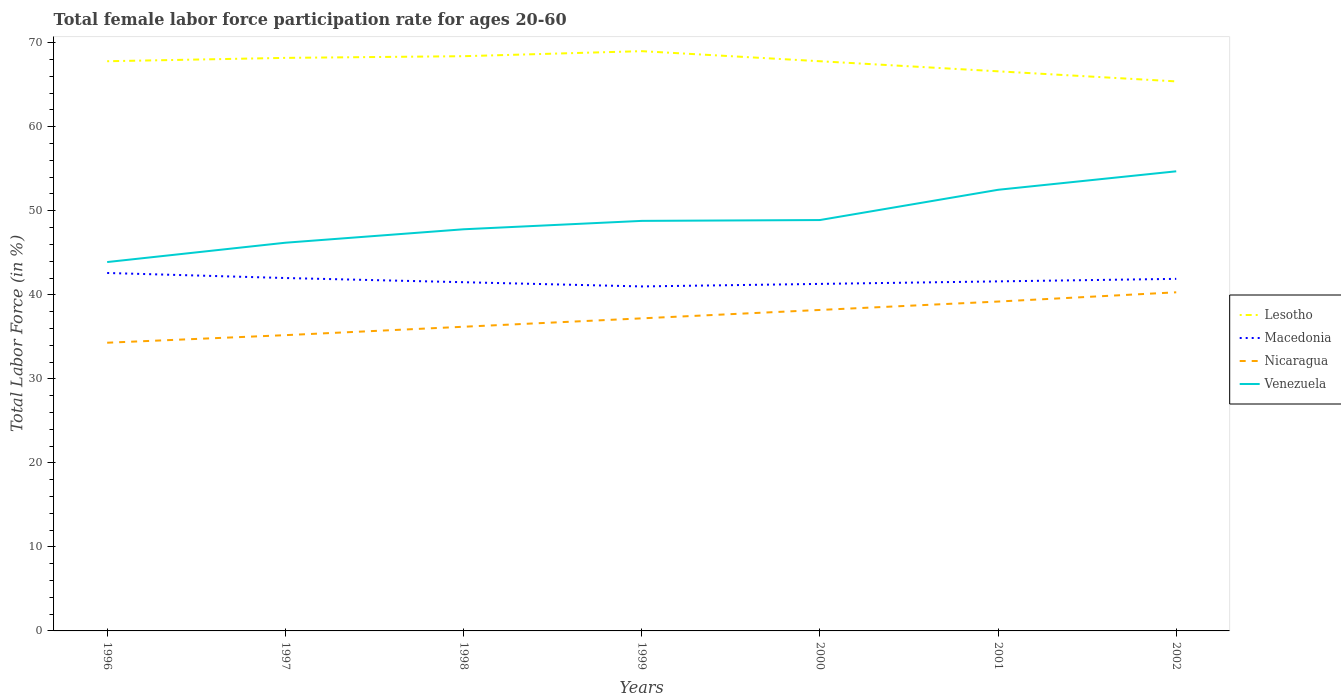Does the line corresponding to Venezuela intersect with the line corresponding to Nicaragua?
Offer a very short reply. No. Is the number of lines equal to the number of legend labels?
Make the answer very short. Yes. Across all years, what is the maximum female labor force participation rate in Lesotho?
Make the answer very short. 65.4. What is the total female labor force participation rate in Venezuela in the graph?
Provide a short and direct response. -8.6. What is the difference between the highest and the second highest female labor force participation rate in Macedonia?
Keep it short and to the point. 1.6. Is the female labor force participation rate in Macedonia strictly greater than the female labor force participation rate in Venezuela over the years?
Your response must be concise. Yes. How many lines are there?
Make the answer very short. 4. How many years are there in the graph?
Provide a short and direct response. 7. Are the values on the major ticks of Y-axis written in scientific E-notation?
Provide a succinct answer. No. Does the graph contain any zero values?
Provide a succinct answer. No. How are the legend labels stacked?
Your answer should be very brief. Vertical. What is the title of the graph?
Provide a short and direct response. Total female labor force participation rate for ages 20-60. Does "Turkey" appear as one of the legend labels in the graph?
Offer a terse response. No. What is the label or title of the X-axis?
Keep it short and to the point. Years. What is the Total Labor Force (in %) in Lesotho in 1996?
Ensure brevity in your answer.  67.8. What is the Total Labor Force (in %) of Macedonia in 1996?
Offer a terse response. 42.6. What is the Total Labor Force (in %) of Nicaragua in 1996?
Your answer should be very brief. 34.3. What is the Total Labor Force (in %) in Venezuela in 1996?
Offer a terse response. 43.9. What is the Total Labor Force (in %) in Lesotho in 1997?
Make the answer very short. 68.2. What is the Total Labor Force (in %) of Macedonia in 1997?
Provide a short and direct response. 42. What is the Total Labor Force (in %) in Nicaragua in 1997?
Ensure brevity in your answer.  35.2. What is the Total Labor Force (in %) in Venezuela in 1997?
Your response must be concise. 46.2. What is the Total Labor Force (in %) in Lesotho in 1998?
Provide a short and direct response. 68.4. What is the Total Labor Force (in %) of Macedonia in 1998?
Give a very brief answer. 41.5. What is the Total Labor Force (in %) in Nicaragua in 1998?
Ensure brevity in your answer.  36.2. What is the Total Labor Force (in %) in Venezuela in 1998?
Make the answer very short. 47.8. What is the Total Labor Force (in %) in Nicaragua in 1999?
Offer a very short reply. 37.2. What is the Total Labor Force (in %) in Venezuela in 1999?
Keep it short and to the point. 48.8. What is the Total Labor Force (in %) of Lesotho in 2000?
Give a very brief answer. 67.8. What is the Total Labor Force (in %) of Macedonia in 2000?
Your answer should be very brief. 41.3. What is the Total Labor Force (in %) in Nicaragua in 2000?
Make the answer very short. 38.2. What is the Total Labor Force (in %) of Venezuela in 2000?
Give a very brief answer. 48.9. What is the Total Labor Force (in %) of Lesotho in 2001?
Provide a succinct answer. 66.6. What is the Total Labor Force (in %) of Macedonia in 2001?
Provide a succinct answer. 41.6. What is the Total Labor Force (in %) of Nicaragua in 2001?
Ensure brevity in your answer.  39.2. What is the Total Labor Force (in %) of Venezuela in 2001?
Ensure brevity in your answer.  52.5. What is the Total Labor Force (in %) of Lesotho in 2002?
Provide a succinct answer. 65.4. What is the Total Labor Force (in %) in Macedonia in 2002?
Keep it short and to the point. 41.9. What is the Total Labor Force (in %) in Nicaragua in 2002?
Give a very brief answer. 40.3. What is the Total Labor Force (in %) in Venezuela in 2002?
Your answer should be compact. 54.7. Across all years, what is the maximum Total Labor Force (in %) of Macedonia?
Your answer should be very brief. 42.6. Across all years, what is the maximum Total Labor Force (in %) in Nicaragua?
Ensure brevity in your answer.  40.3. Across all years, what is the maximum Total Labor Force (in %) of Venezuela?
Make the answer very short. 54.7. Across all years, what is the minimum Total Labor Force (in %) of Lesotho?
Offer a very short reply. 65.4. Across all years, what is the minimum Total Labor Force (in %) of Nicaragua?
Your answer should be compact. 34.3. Across all years, what is the minimum Total Labor Force (in %) in Venezuela?
Keep it short and to the point. 43.9. What is the total Total Labor Force (in %) in Lesotho in the graph?
Keep it short and to the point. 473.2. What is the total Total Labor Force (in %) of Macedonia in the graph?
Give a very brief answer. 291.9. What is the total Total Labor Force (in %) of Nicaragua in the graph?
Provide a succinct answer. 260.6. What is the total Total Labor Force (in %) in Venezuela in the graph?
Provide a short and direct response. 342.8. What is the difference between the Total Labor Force (in %) of Macedonia in 1996 and that in 1997?
Your response must be concise. 0.6. What is the difference between the Total Labor Force (in %) in Venezuela in 1996 and that in 1997?
Ensure brevity in your answer.  -2.3. What is the difference between the Total Labor Force (in %) in Lesotho in 1996 and that in 1998?
Offer a terse response. -0.6. What is the difference between the Total Labor Force (in %) in Macedonia in 1996 and that in 1998?
Give a very brief answer. 1.1. What is the difference between the Total Labor Force (in %) of Nicaragua in 1996 and that in 1998?
Ensure brevity in your answer.  -1.9. What is the difference between the Total Labor Force (in %) in Macedonia in 1996 and that in 1999?
Make the answer very short. 1.6. What is the difference between the Total Labor Force (in %) of Lesotho in 1996 and that in 2000?
Keep it short and to the point. 0. What is the difference between the Total Labor Force (in %) of Macedonia in 1996 and that in 2000?
Offer a terse response. 1.3. What is the difference between the Total Labor Force (in %) in Venezuela in 1996 and that in 2000?
Provide a short and direct response. -5. What is the difference between the Total Labor Force (in %) of Macedonia in 1996 and that in 2001?
Keep it short and to the point. 1. What is the difference between the Total Labor Force (in %) of Lesotho in 1996 and that in 2002?
Give a very brief answer. 2.4. What is the difference between the Total Labor Force (in %) of Nicaragua in 1996 and that in 2002?
Your answer should be very brief. -6. What is the difference between the Total Labor Force (in %) in Nicaragua in 1997 and that in 1998?
Ensure brevity in your answer.  -1. What is the difference between the Total Labor Force (in %) in Lesotho in 1997 and that in 1999?
Ensure brevity in your answer.  -0.8. What is the difference between the Total Labor Force (in %) in Macedonia in 1997 and that in 1999?
Make the answer very short. 1. What is the difference between the Total Labor Force (in %) of Lesotho in 1997 and that in 2000?
Provide a succinct answer. 0.4. What is the difference between the Total Labor Force (in %) of Nicaragua in 1997 and that in 2000?
Keep it short and to the point. -3. What is the difference between the Total Labor Force (in %) of Venezuela in 1997 and that in 2000?
Your answer should be very brief. -2.7. What is the difference between the Total Labor Force (in %) of Lesotho in 1997 and that in 2001?
Offer a very short reply. 1.6. What is the difference between the Total Labor Force (in %) of Nicaragua in 1997 and that in 2001?
Offer a terse response. -4. What is the difference between the Total Labor Force (in %) in Venezuela in 1997 and that in 2002?
Ensure brevity in your answer.  -8.5. What is the difference between the Total Labor Force (in %) in Nicaragua in 1998 and that in 1999?
Your response must be concise. -1. What is the difference between the Total Labor Force (in %) in Lesotho in 1998 and that in 2000?
Make the answer very short. 0.6. What is the difference between the Total Labor Force (in %) in Venezuela in 1998 and that in 2000?
Provide a short and direct response. -1.1. What is the difference between the Total Labor Force (in %) in Macedonia in 1998 and that in 2001?
Give a very brief answer. -0.1. What is the difference between the Total Labor Force (in %) in Venezuela in 1998 and that in 2001?
Your answer should be compact. -4.7. What is the difference between the Total Labor Force (in %) in Macedonia in 1998 and that in 2002?
Keep it short and to the point. -0.4. What is the difference between the Total Labor Force (in %) in Venezuela in 1998 and that in 2002?
Provide a succinct answer. -6.9. What is the difference between the Total Labor Force (in %) of Lesotho in 1999 and that in 2000?
Ensure brevity in your answer.  1.2. What is the difference between the Total Labor Force (in %) of Macedonia in 1999 and that in 2000?
Ensure brevity in your answer.  -0.3. What is the difference between the Total Labor Force (in %) in Nicaragua in 1999 and that in 2000?
Offer a terse response. -1. What is the difference between the Total Labor Force (in %) of Nicaragua in 1999 and that in 2002?
Ensure brevity in your answer.  -3.1. What is the difference between the Total Labor Force (in %) of Venezuela in 1999 and that in 2002?
Ensure brevity in your answer.  -5.9. What is the difference between the Total Labor Force (in %) in Lesotho in 2000 and that in 2001?
Your answer should be very brief. 1.2. What is the difference between the Total Labor Force (in %) of Nicaragua in 2000 and that in 2001?
Make the answer very short. -1. What is the difference between the Total Labor Force (in %) of Nicaragua in 2000 and that in 2002?
Keep it short and to the point. -2.1. What is the difference between the Total Labor Force (in %) in Venezuela in 2000 and that in 2002?
Give a very brief answer. -5.8. What is the difference between the Total Labor Force (in %) in Nicaragua in 2001 and that in 2002?
Offer a terse response. -1.1. What is the difference between the Total Labor Force (in %) in Venezuela in 2001 and that in 2002?
Make the answer very short. -2.2. What is the difference between the Total Labor Force (in %) of Lesotho in 1996 and the Total Labor Force (in %) of Macedonia in 1997?
Offer a very short reply. 25.8. What is the difference between the Total Labor Force (in %) of Lesotho in 1996 and the Total Labor Force (in %) of Nicaragua in 1997?
Offer a very short reply. 32.6. What is the difference between the Total Labor Force (in %) in Lesotho in 1996 and the Total Labor Force (in %) in Venezuela in 1997?
Your answer should be compact. 21.6. What is the difference between the Total Labor Force (in %) in Macedonia in 1996 and the Total Labor Force (in %) in Venezuela in 1997?
Make the answer very short. -3.6. What is the difference between the Total Labor Force (in %) of Lesotho in 1996 and the Total Labor Force (in %) of Macedonia in 1998?
Provide a succinct answer. 26.3. What is the difference between the Total Labor Force (in %) of Lesotho in 1996 and the Total Labor Force (in %) of Nicaragua in 1998?
Ensure brevity in your answer.  31.6. What is the difference between the Total Labor Force (in %) of Lesotho in 1996 and the Total Labor Force (in %) of Venezuela in 1998?
Offer a very short reply. 20. What is the difference between the Total Labor Force (in %) of Macedonia in 1996 and the Total Labor Force (in %) of Venezuela in 1998?
Your response must be concise. -5.2. What is the difference between the Total Labor Force (in %) in Lesotho in 1996 and the Total Labor Force (in %) in Macedonia in 1999?
Ensure brevity in your answer.  26.8. What is the difference between the Total Labor Force (in %) of Lesotho in 1996 and the Total Labor Force (in %) of Nicaragua in 1999?
Give a very brief answer. 30.6. What is the difference between the Total Labor Force (in %) in Lesotho in 1996 and the Total Labor Force (in %) in Venezuela in 1999?
Your response must be concise. 19. What is the difference between the Total Labor Force (in %) in Macedonia in 1996 and the Total Labor Force (in %) in Venezuela in 1999?
Provide a succinct answer. -6.2. What is the difference between the Total Labor Force (in %) in Nicaragua in 1996 and the Total Labor Force (in %) in Venezuela in 1999?
Make the answer very short. -14.5. What is the difference between the Total Labor Force (in %) in Lesotho in 1996 and the Total Labor Force (in %) in Macedonia in 2000?
Your response must be concise. 26.5. What is the difference between the Total Labor Force (in %) of Lesotho in 1996 and the Total Labor Force (in %) of Nicaragua in 2000?
Your answer should be very brief. 29.6. What is the difference between the Total Labor Force (in %) in Nicaragua in 1996 and the Total Labor Force (in %) in Venezuela in 2000?
Ensure brevity in your answer.  -14.6. What is the difference between the Total Labor Force (in %) of Lesotho in 1996 and the Total Labor Force (in %) of Macedonia in 2001?
Your response must be concise. 26.2. What is the difference between the Total Labor Force (in %) of Lesotho in 1996 and the Total Labor Force (in %) of Nicaragua in 2001?
Offer a very short reply. 28.6. What is the difference between the Total Labor Force (in %) of Macedonia in 1996 and the Total Labor Force (in %) of Nicaragua in 2001?
Your answer should be compact. 3.4. What is the difference between the Total Labor Force (in %) in Macedonia in 1996 and the Total Labor Force (in %) in Venezuela in 2001?
Ensure brevity in your answer.  -9.9. What is the difference between the Total Labor Force (in %) of Nicaragua in 1996 and the Total Labor Force (in %) of Venezuela in 2001?
Give a very brief answer. -18.2. What is the difference between the Total Labor Force (in %) of Lesotho in 1996 and the Total Labor Force (in %) of Macedonia in 2002?
Offer a terse response. 25.9. What is the difference between the Total Labor Force (in %) in Lesotho in 1996 and the Total Labor Force (in %) in Nicaragua in 2002?
Your answer should be compact. 27.5. What is the difference between the Total Labor Force (in %) of Lesotho in 1996 and the Total Labor Force (in %) of Venezuela in 2002?
Offer a terse response. 13.1. What is the difference between the Total Labor Force (in %) of Nicaragua in 1996 and the Total Labor Force (in %) of Venezuela in 2002?
Make the answer very short. -20.4. What is the difference between the Total Labor Force (in %) in Lesotho in 1997 and the Total Labor Force (in %) in Macedonia in 1998?
Keep it short and to the point. 26.7. What is the difference between the Total Labor Force (in %) of Lesotho in 1997 and the Total Labor Force (in %) of Nicaragua in 1998?
Give a very brief answer. 32. What is the difference between the Total Labor Force (in %) in Lesotho in 1997 and the Total Labor Force (in %) in Venezuela in 1998?
Make the answer very short. 20.4. What is the difference between the Total Labor Force (in %) in Nicaragua in 1997 and the Total Labor Force (in %) in Venezuela in 1998?
Offer a very short reply. -12.6. What is the difference between the Total Labor Force (in %) in Lesotho in 1997 and the Total Labor Force (in %) in Macedonia in 1999?
Your answer should be compact. 27.2. What is the difference between the Total Labor Force (in %) of Macedonia in 1997 and the Total Labor Force (in %) of Venezuela in 1999?
Ensure brevity in your answer.  -6.8. What is the difference between the Total Labor Force (in %) of Lesotho in 1997 and the Total Labor Force (in %) of Macedonia in 2000?
Give a very brief answer. 26.9. What is the difference between the Total Labor Force (in %) of Lesotho in 1997 and the Total Labor Force (in %) of Nicaragua in 2000?
Provide a succinct answer. 30. What is the difference between the Total Labor Force (in %) of Lesotho in 1997 and the Total Labor Force (in %) of Venezuela in 2000?
Give a very brief answer. 19.3. What is the difference between the Total Labor Force (in %) of Macedonia in 1997 and the Total Labor Force (in %) of Nicaragua in 2000?
Make the answer very short. 3.8. What is the difference between the Total Labor Force (in %) in Nicaragua in 1997 and the Total Labor Force (in %) in Venezuela in 2000?
Keep it short and to the point. -13.7. What is the difference between the Total Labor Force (in %) in Lesotho in 1997 and the Total Labor Force (in %) in Macedonia in 2001?
Provide a succinct answer. 26.6. What is the difference between the Total Labor Force (in %) in Lesotho in 1997 and the Total Labor Force (in %) in Nicaragua in 2001?
Your answer should be compact. 29. What is the difference between the Total Labor Force (in %) of Macedonia in 1997 and the Total Labor Force (in %) of Venezuela in 2001?
Provide a short and direct response. -10.5. What is the difference between the Total Labor Force (in %) of Nicaragua in 1997 and the Total Labor Force (in %) of Venezuela in 2001?
Your response must be concise. -17.3. What is the difference between the Total Labor Force (in %) of Lesotho in 1997 and the Total Labor Force (in %) of Macedonia in 2002?
Give a very brief answer. 26.3. What is the difference between the Total Labor Force (in %) in Lesotho in 1997 and the Total Labor Force (in %) in Nicaragua in 2002?
Give a very brief answer. 27.9. What is the difference between the Total Labor Force (in %) of Macedonia in 1997 and the Total Labor Force (in %) of Nicaragua in 2002?
Ensure brevity in your answer.  1.7. What is the difference between the Total Labor Force (in %) in Nicaragua in 1997 and the Total Labor Force (in %) in Venezuela in 2002?
Make the answer very short. -19.5. What is the difference between the Total Labor Force (in %) of Lesotho in 1998 and the Total Labor Force (in %) of Macedonia in 1999?
Keep it short and to the point. 27.4. What is the difference between the Total Labor Force (in %) in Lesotho in 1998 and the Total Labor Force (in %) in Nicaragua in 1999?
Make the answer very short. 31.2. What is the difference between the Total Labor Force (in %) of Lesotho in 1998 and the Total Labor Force (in %) of Venezuela in 1999?
Provide a succinct answer. 19.6. What is the difference between the Total Labor Force (in %) in Macedonia in 1998 and the Total Labor Force (in %) in Venezuela in 1999?
Provide a short and direct response. -7.3. What is the difference between the Total Labor Force (in %) in Nicaragua in 1998 and the Total Labor Force (in %) in Venezuela in 1999?
Your response must be concise. -12.6. What is the difference between the Total Labor Force (in %) of Lesotho in 1998 and the Total Labor Force (in %) of Macedonia in 2000?
Offer a terse response. 27.1. What is the difference between the Total Labor Force (in %) in Lesotho in 1998 and the Total Labor Force (in %) in Nicaragua in 2000?
Your response must be concise. 30.2. What is the difference between the Total Labor Force (in %) of Lesotho in 1998 and the Total Labor Force (in %) of Venezuela in 2000?
Provide a succinct answer. 19.5. What is the difference between the Total Labor Force (in %) in Macedonia in 1998 and the Total Labor Force (in %) in Venezuela in 2000?
Give a very brief answer. -7.4. What is the difference between the Total Labor Force (in %) in Lesotho in 1998 and the Total Labor Force (in %) in Macedonia in 2001?
Keep it short and to the point. 26.8. What is the difference between the Total Labor Force (in %) of Lesotho in 1998 and the Total Labor Force (in %) of Nicaragua in 2001?
Offer a terse response. 29.2. What is the difference between the Total Labor Force (in %) in Lesotho in 1998 and the Total Labor Force (in %) in Venezuela in 2001?
Ensure brevity in your answer.  15.9. What is the difference between the Total Labor Force (in %) in Macedonia in 1998 and the Total Labor Force (in %) in Nicaragua in 2001?
Your response must be concise. 2.3. What is the difference between the Total Labor Force (in %) in Nicaragua in 1998 and the Total Labor Force (in %) in Venezuela in 2001?
Your answer should be compact. -16.3. What is the difference between the Total Labor Force (in %) of Lesotho in 1998 and the Total Labor Force (in %) of Nicaragua in 2002?
Your answer should be very brief. 28.1. What is the difference between the Total Labor Force (in %) of Lesotho in 1998 and the Total Labor Force (in %) of Venezuela in 2002?
Your answer should be very brief. 13.7. What is the difference between the Total Labor Force (in %) of Macedonia in 1998 and the Total Labor Force (in %) of Venezuela in 2002?
Provide a succinct answer. -13.2. What is the difference between the Total Labor Force (in %) of Nicaragua in 1998 and the Total Labor Force (in %) of Venezuela in 2002?
Keep it short and to the point. -18.5. What is the difference between the Total Labor Force (in %) of Lesotho in 1999 and the Total Labor Force (in %) of Macedonia in 2000?
Offer a very short reply. 27.7. What is the difference between the Total Labor Force (in %) of Lesotho in 1999 and the Total Labor Force (in %) of Nicaragua in 2000?
Your answer should be very brief. 30.8. What is the difference between the Total Labor Force (in %) in Lesotho in 1999 and the Total Labor Force (in %) in Venezuela in 2000?
Your response must be concise. 20.1. What is the difference between the Total Labor Force (in %) in Macedonia in 1999 and the Total Labor Force (in %) in Venezuela in 2000?
Ensure brevity in your answer.  -7.9. What is the difference between the Total Labor Force (in %) of Nicaragua in 1999 and the Total Labor Force (in %) of Venezuela in 2000?
Keep it short and to the point. -11.7. What is the difference between the Total Labor Force (in %) in Lesotho in 1999 and the Total Labor Force (in %) in Macedonia in 2001?
Make the answer very short. 27.4. What is the difference between the Total Labor Force (in %) of Lesotho in 1999 and the Total Labor Force (in %) of Nicaragua in 2001?
Keep it short and to the point. 29.8. What is the difference between the Total Labor Force (in %) in Macedonia in 1999 and the Total Labor Force (in %) in Nicaragua in 2001?
Your answer should be very brief. 1.8. What is the difference between the Total Labor Force (in %) of Macedonia in 1999 and the Total Labor Force (in %) of Venezuela in 2001?
Provide a short and direct response. -11.5. What is the difference between the Total Labor Force (in %) in Nicaragua in 1999 and the Total Labor Force (in %) in Venezuela in 2001?
Your response must be concise. -15.3. What is the difference between the Total Labor Force (in %) in Lesotho in 1999 and the Total Labor Force (in %) in Macedonia in 2002?
Ensure brevity in your answer.  27.1. What is the difference between the Total Labor Force (in %) in Lesotho in 1999 and the Total Labor Force (in %) in Nicaragua in 2002?
Your answer should be compact. 28.7. What is the difference between the Total Labor Force (in %) in Lesotho in 1999 and the Total Labor Force (in %) in Venezuela in 2002?
Your answer should be very brief. 14.3. What is the difference between the Total Labor Force (in %) in Macedonia in 1999 and the Total Labor Force (in %) in Nicaragua in 2002?
Your answer should be very brief. 0.7. What is the difference between the Total Labor Force (in %) in Macedonia in 1999 and the Total Labor Force (in %) in Venezuela in 2002?
Give a very brief answer. -13.7. What is the difference between the Total Labor Force (in %) in Nicaragua in 1999 and the Total Labor Force (in %) in Venezuela in 2002?
Provide a succinct answer. -17.5. What is the difference between the Total Labor Force (in %) in Lesotho in 2000 and the Total Labor Force (in %) in Macedonia in 2001?
Ensure brevity in your answer.  26.2. What is the difference between the Total Labor Force (in %) in Lesotho in 2000 and the Total Labor Force (in %) in Nicaragua in 2001?
Your answer should be very brief. 28.6. What is the difference between the Total Labor Force (in %) in Nicaragua in 2000 and the Total Labor Force (in %) in Venezuela in 2001?
Your answer should be compact. -14.3. What is the difference between the Total Labor Force (in %) of Lesotho in 2000 and the Total Labor Force (in %) of Macedonia in 2002?
Your answer should be compact. 25.9. What is the difference between the Total Labor Force (in %) of Lesotho in 2000 and the Total Labor Force (in %) of Nicaragua in 2002?
Provide a succinct answer. 27.5. What is the difference between the Total Labor Force (in %) of Lesotho in 2000 and the Total Labor Force (in %) of Venezuela in 2002?
Your answer should be compact. 13.1. What is the difference between the Total Labor Force (in %) of Macedonia in 2000 and the Total Labor Force (in %) of Nicaragua in 2002?
Provide a succinct answer. 1. What is the difference between the Total Labor Force (in %) of Macedonia in 2000 and the Total Labor Force (in %) of Venezuela in 2002?
Ensure brevity in your answer.  -13.4. What is the difference between the Total Labor Force (in %) in Nicaragua in 2000 and the Total Labor Force (in %) in Venezuela in 2002?
Your response must be concise. -16.5. What is the difference between the Total Labor Force (in %) of Lesotho in 2001 and the Total Labor Force (in %) of Macedonia in 2002?
Keep it short and to the point. 24.7. What is the difference between the Total Labor Force (in %) of Lesotho in 2001 and the Total Labor Force (in %) of Nicaragua in 2002?
Give a very brief answer. 26.3. What is the difference between the Total Labor Force (in %) of Lesotho in 2001 and the Total Labor Force (in %) of Venezuela in 2002?
Ensure brevity in your answer.  11.9. What is the difference between the Total Labor Force (in %) in Macedonia in 2001 and the Total Labor Force (in %) in Venezuela in 2002?
Provide a succinct answer. -13.1. What is the difference between the Total Labor Force (in %) of Nicaragua in 2001 and the Total Labor Force (in %) of Venezuela in 2002?
Give a very brief answer. -15.5. What is the average Total Labor Force (in %) of Lesotho per year?
Give a very brief answer. 67.6. What is the average Total Labor Force (in %) in Macedonia per year?
Make the answer very short. 41.7. What is the average Total Labor Force (in %) of Nicaragua per year?
Make the answer very short. 37.23. What is the average Total Labor Force (in %) of Venezuela per year?
Provide a succinct answer. 48.97. In the year 1996, what is the difference between the Total Labor Force (in %) of Lesotho and Total Labor Force (in %) of Macedonia?
Give a very brief answer. 25.2. In the year 1996, what is the difference between the Total Labor Force (in %) in Lesotho and Total Labor Force (in %) in Nicaragua?
Offer a terse response. 33.5. In the year 1996, what is the difference between the Total Labor Force (in %) in Lesotho and Total Labor Force (in %) in Venezuela?
Your answer should be very brief. 23.9. In the year 1996, what is the difference between the Total Labor Force (in %) of Macedonia and Total Labor Force (in %) of Nicaragua?
Give a very brief answer. 8.3. In the year 1996, what is the difference between the Total Labor Force (in %) of Nicaragua and Total Labor Force (in %) of Venezuela?
Make the answer very short. -9.6. In the year 1997, what is the difference between the Total Labor Force (in %) of Lesotho and Total Labor Force (in %) of Macedonia?
Provide a succinct answer. 26.2. In the year 1997, what is the difference between the Total Labor Force (in %) in Macedonia and Total Labor Force (in %) in Nicaragua?
Give a very brief answer. 6.8. In the year 1997, what is the difference between the Total Labor Force (in %) of Macedonia and Total Labor Force (in %) of Venezuela?
Give a very brief answer. -4.2. In the year 1998, what is the difference between the Total Labor Force (in %) of Lesotho and Total Labor Force (in %) of Macedonia?
Your response must be concise. 26.9. In the year 1998, what is the difference between the Total Labor Force (in %) in Lesotho and Total Labor Force (in %) in Nicaragua?
Your response must be concise. 32.2. In the year 1998, what is the difference between the Total Labor Force (in %) in Lesotho and Total Labor Force (in %) in Venezuela?
Offer a very short reply. 20.6. In the year 1998, what is the difference between the Total Labor Force (in %) of Macedonia and Total Labor Force (in %) of Venezuela?
Provide a short and direct response. -6.3. In the year 1999, what is the difference between the Total Labor Force (in %) in Lesotho and Total Labor Force (in %) in Nicaragua?
Provide a short and direct response. 31.8. In the year 1999, what is the difference between the Total Labor Force (in %) in Lesotho and Total Labor Force (in %) in Venezuela?
Provide a succinct answer. 20.2. In the year 2000, what is the difference between the Total Labor Force (in %) of Lesotho and Total Labor Force (in %) of Macedonia?
Make the answer very short. 26.5. In the year 2000, what is the difference between the Total Labor Force (in %) of Lesotho and Total Labor Force (in %) of Nicaragua?
Provide a succinct answer. 29.6. In the year 2000, what is the difference between the Total Labor Force (in %) in Lesotho and Total Labor Force (in %) in Venezuela?
Offer a very short reply. 18.9. In the year 2000, what is the difference between the Total Labor Force (in %) of Macedonia and Total Labor Force (in %) of Venezuela?
Provide a short and direct response. -7.6. In the year 2001, what is the difference between the Total Labor Force (in %) of Lesotho and Total Labor Force (in %) of Nicaragua?
Make the answer very short. 27.4. In the year 2001, what is the difference between the Total Labor Force (in %) in Lesotho and Total Labor Force (in %) in Venezuela?
Keep it short and to the point. 14.1. In the year 2001, what is the difference between the Total Labor Force (in %) in Macedonia and Total Labor Force (in %) in Nicaragua?
Keep it short and to the point. 2.4. In the year 2001, what is the difference between the Total Labor Force (in %) of Nicaragua and Total Labor Force (in %) of Venezuela?
Your answer should be very brief. -13.3. In the year 2002, what is the difference between the Total Labor Force (in %) of Lesotho and Total Labor Force (in %) of Macedonia?
Provide a succinct answer. 23.5. In the year 2002, what is the difference between the Total Labor Force (in %) of Lesotho and Total Labor Force (in %) of Nicaragua?
Offer a terse response. 25.1. In the year 2002, what is the difference between the Total Labor Force (in %) in Macedonia and Total Labor Force (in %) in Nicaragua?
Give a very brief answer. 1.6. In the year 2002, what is the difference between the Total Labor Force (in %) in Nicaragua and Total Labor Force (in %) in Venezuela?
Ensure brevity in your answer.  -14.4. What is the ratio of the Total Labor Force (in %) of Lesotho in 1996 to that in 1997?
Offer a terse response. 0.99. What is the ratio of the Total Labor Force (in %) of Macedonia in 1996 to that in 1997?
Give a very brief answer. 1.01. What is the ratio of the Total Labor Force (in %) in Nicaragua in 1996 to that in 1997?
Ensure brevity in your answer.  0.97. What is the ratio of the Total Labor Force (in %) in Venezuela in 1996 to that in 1997?
Your response must be concise. 0.95. What is the ratio of the Total Labor Force (in %) in Lesotho in 1996 to that in 1998?
Provide a short and direct response. 0.99. What is the ratio of the Total Labor Force (in %) in Macedonia in 1996 to that in 1998?
Offer a very short reply. 1.03. What is the ratio of the Total Labor Force (in %) in Nicaragua in 1996 to that in 1998?
Offer a very short reply. 0.95. What is the ratio of the Total Labor Force (in %) of Venezuela in 1996 to that in 1998?
Your answer should be very brief. 0.92. What is the ratio of the Total Labor Force (in %) in Lesotho in 1996 to that in 1999?
Ensure brevity in your answer.  0.98. What is the ratio of the Total Labor Force (in %) in Macedonia in 1996 to that in 1999?
Ensure brevity in your answer.  1.04. What is the ratio of the Total Labor Force (in %) in Nicaragua in 1996 to that in 1999?
Make the answer very short. 0.92. What is the ratio of the Total Labor Force (in %) of Venezuela in 1996 to that in 1999?
Keep it short and to the point. 0.9. What is the ratio of the Total Labor Force (in %) in Lesotho in 1996 to that in 2000?
Your response must be concise. 1. What is the ratio of the Total Labor Force (in %) in Macedonia in 1996 to that in 2000?
Offer a terse response. 1.03. What is the ratio of the Total Labor Force (in %) of Nicaragua in 1996 to that in 2000?
Keep it short and to the point. 0.9. What is the ratio of the Total Labor Force (in %) in Venezuela in 1996 to that in 2000?
Your answer should be compact. 0.9. What is the ratio of the Total Labor Force (in %) of Macedonia in 1996 to that in 2001?
Provide a short and direct response. 1.02. What is the ratio of the Total Labor Force (in %) of Venezuela in 1996 to that in 2001?
Ensure brevity in your answer.  0.84. What is the ratio of the Total Labor Force (in %) of Lesotho in 1996 to that in 2002?
Keep it short and to the point. 1.04. What is the ratio of the Total Labor Force (in %) in Macedonia in 1996 to that in 2002?
Make the answer very short. 1.02. What is the ratio of the Total Labor Force (in %) in Nicaragua in 1996 to that in 2002?
Keep it short and to the point. 0.85. What is the ratio of the Total Labor Force (in %) in Venezuela in 1996 to that in 2002?
Keep it short and to the point. 0.8. What is the ratio of the Total Labor Force (in %) of Nicaragua in 1997 to that in 1998?
Provide a succinct answer. 0.97. What is the ratio of the Total Labor Force (in %) in Venezuela in 1997 to that in 1998?
Your answer should be very brief. 0.97. What is the ratio of the Total Labor Force (in %) of Lesotho in 1997 to that in 1999?
Make the answer very short. 0.99. What is the ratio of the Total Labor Force (in %) of Macedonia in 1997 to that in 1999?
Keep it short and to the point. 1.02. What is the ratio of the Total Labor Force (in %) of Nicaragua in 1997 to that in 1999?
Keep it short and to the point. 0.95. What is the ratio of the Total Labor Force (in %) in Venezuela in 1997 to that in 1999?
Provide a succinct answer. 0.95. What is the ratio of the Total Labor Force (in %) in Lesotho in 1997 to that in 2000?
Offer a terse response. 1.01. What is the ratio of the Total Labor Force (in %) of Macedonia in 1997 to that in 2000?
Your response must be concise. 1.02. What is the ratio of the Total Labor Force (in %) of Nicaragua in 1997 to that in 2000?
Offer a terse response. 0.92. What is the ratio of the Total Labor Force (in %) in Venezuela in 1997 to that in 2000?
Keep it short and to the point. 0.94. What is the ratio of the Total Labor Force (in %) of Lesotho in 1997 to that in 2001?
Offer a very short reply. 1.02. What is the ratio of the Total Labor Force (in %) of Macedonia in 1997 to that in 2001?
Offer a very short reply. 1.01. What is the ratio of the Total Labor Force (in %) in Nicaragua in 1997 to that in 2001?
Give a very brief answer. 0.9. What is the ratio of the Total Labor Force (in %) of Venezuela in 1997 to that in 2001?
Offer a terse response. 0.88. What is the ratio of the Total Labor Force (in %) of Lesotho in 1997 to that in 2002?
Offer a very short reply. 1.04. What is the ratio of the Total Labor Force (in %) in Nicaragua in 1997 to that in 2002?
Ensure brevity in your answer.  0.87. What is the ratio of the Total Labor Force (in %) in Venezuela in 1997 to that in 2002?
Offer a terse response. 0.84. What is the ratio of the Total Labor Force (in %) in Lesotho in 1998 to that in 1999?
Your response must be concise. 0.99. What is the ratio of the Total Labor Force (in %) in Macedonia in 1998 to that in 1999?
Offer a terse response. 1.01. What is the ratio of the Total Labor Force (in %) in Nicaragua in 1998 to that in 1999?
Make the answer very short. 0.97. What is the ratio of the Total Labor Force (in %) in Venezuela in 1998 to that in 1999?
Your answer should be compact. 0.98. What is the ratio of the Total Labor Force (in %) in Lesotho in 1998 to that in 2000?
Provide a short and direct response. 1.01. What is the ratio of the Total Labor Force (in %) in Nicaragua in 1998 to that in 2000?
Your answer should be compact. 0.95. What is the ratio of the Total Labor Force (in %) of Venezuela in 1998 to that in 2000?
Provide a short and direct response. 0.98. What is the ratio of the Total Labor Force (in %) of Nicaragua in 1998 to that in 2001?
Make the answer very short. 0.92. What is the ratio of the Total Labor Force (in %) of Venezuela in 1998 to that in 2001?
Give a very brief answer. 0.91. What is the ratio of the Total Labor Force (in %) in Lesotho in 1998 to that in 2002?
Your answer should be compact. 1.05. What is the ratio of the Total Labor Force (in %) in Nicaragua in 1998 to that in 2002?
Offer a terse response. 0.9. What is the ratio of the Total Labor Force (in %) of Venezuela in 1998 to that in 2002?
Provide a succinct answer. 0.87. What is the ratio of the Total Labor Force (in %) in Lesotho in 1999 to that in 2000?
Make the answer very short. 1.02. What is the ratio of the Total Labor Force (in %) in Macedonia in 1999 to that in 2000?
Give a very brief answer. 0.99. What is the ratio of the Total Labor Force (in %) of Nicaragua in 1999 to that in 2000?
Offer a very short reply. 0.97. What is the ratio of the Total Labor Force (in %) in Lesotho in 1999 to that in 2001?
Keep it short and to the point. 1.04. What is the ratio of the Total Labor Force (in %) in Macedonia in 1999 to that in 2001?
Provide a succinct answer. 0.99. What is the ratio of the Total Labor Force (in %) in Nicaragua in 1999 to that in 2001?
Make the answer very short. 0.95. What is the ratio of the Total Labor Force (in %) in Venezuela in 1999 to that in 2001?
Offer a terse response. 0.93. What is the ratio of the Total Labor Force (in %) of Lesotho in 1999 to that in 2002?
Offer a very short reply. 1.05. What is the ratio of the Total Labor Force (in %) of Macedonia in 1999 to that in 2002?
Provide a short and direct response. 0.98. What is the ratio of the Total Labor Force (in %) of Nicaragua in 1999 to that in 2002?
Provide a short and direct response. 0.92. What is the ratio of the Total Labor Force (in %) of Venezuela in 1999 to that in 2002?
Offer a very short reply. 0.89. What is the ratio of the Total Labor Force (in %) in Nicaragua in 2000 to that in 2001?
Make the answer very short. 0.97. What is the ratio of the Total Labor Force (in %) of Venezuela in 2000 to that in 2001?
Give a very brief answer. 0.93. What is the ratio of the Total Labor Force (in %) of Lesotho in 2000 to that in 2002?
Make the answer very short. 1.04. What is the ratio of the Total Labor Force (in %) of Macedonia in 2000 to that in 2002?
Your response must be concise. 0.99. What is the ratio of the Total Labor Force (in %) of Nicaragua in 2000 to that in 2002?
Make the answer very short. 0.95. What is the ratio of the Total Labor Force (in %) of Venezuela in 2000 to that in 2002?
Provide a short and direct response. 0.89. What is the ratio of the Total Labor Force (in %) of Lesotho in 2001 to that in 2002?
Provide a succinct answer. 1.02. What is the ratio of the Total Labor Force (in %) of Macedonia in 2001 to that in 2002?
Your response must be concise. 0.99. What is the ratio of the Total Labor Force (in %) in Nicaragua in 2001 to that in 2002?
Offer a very short reply. 0.97. What is the ratio of the Total Labor Force (in %) of Venezuela in 2001 to that in 2002?
Your response must be concise. 0.96. What is the difference between the highest and the second highest Total Labor Force (in %) in Macedonia?
Ensure brevity in your answer.  0.6. 